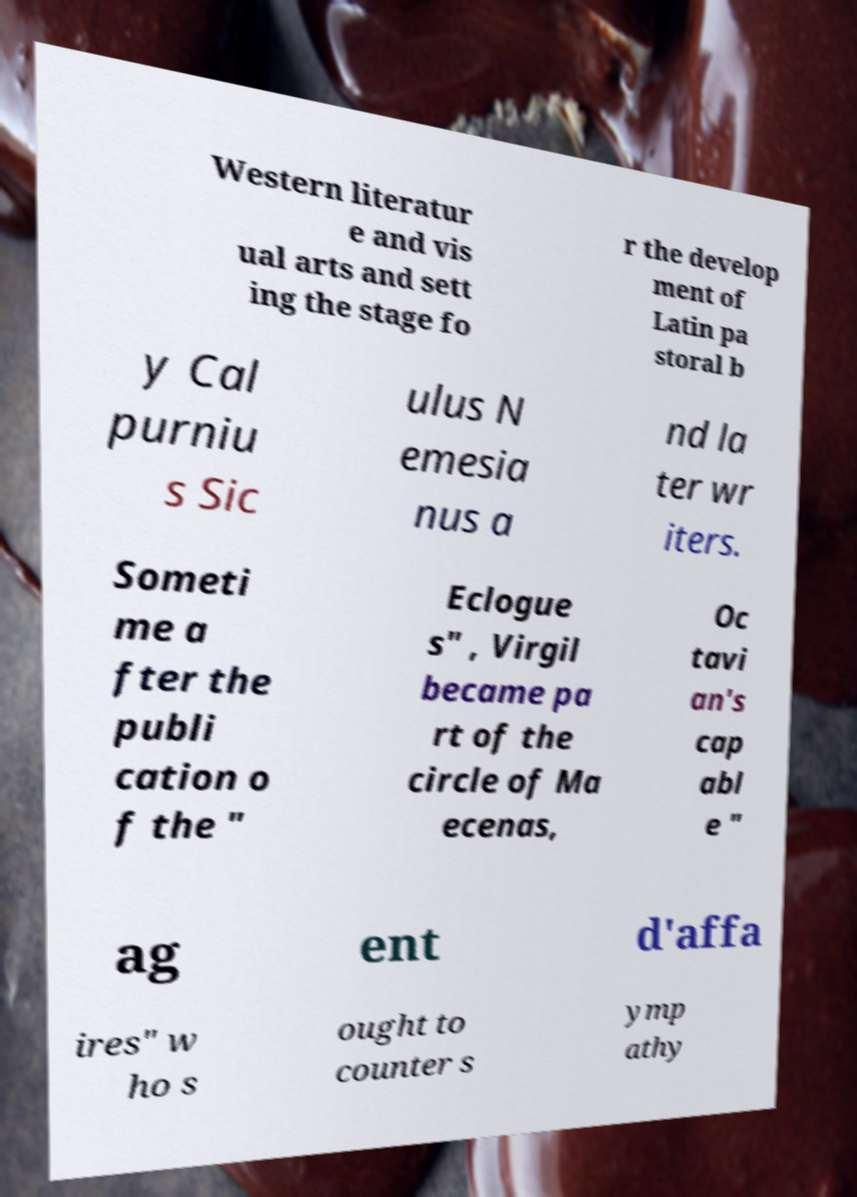There's text embedded in this image that I need extracted. Can you transcribe it verbatim? Western literatur e and vis ual arts and sett ing the stage fo r the develop ment of Latin pa storal b y Cal purniu s Sic ulus N emesia nus a nd la ter wr iters. Someti me a fter the publi cation o f the " Eclogue s" , Virgil became pa rt of the circle of Ma ecenas, Oc tavi an's cap abl e " ag ent d'affa ires" w ho s ought to counter s ymp athy 